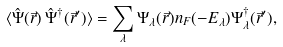<formula> <loc_0><loc_0><loc_500><loc_500>\langle \hat { \Psi } ( \vec { r } ) \, \hat { \Psi } ^ { \dagger } ( \vec { r } ^ { \prime } ) \rangle = \sum _ { \lambda } \Psi _ { \lambda } ( \vec { r } ) n _ { F } ( - E _ { \lambda } ) \Psi ^ { \dagger } _ { \lambda } ( \vec { r } ^ { \prime } ) ,</formula> 